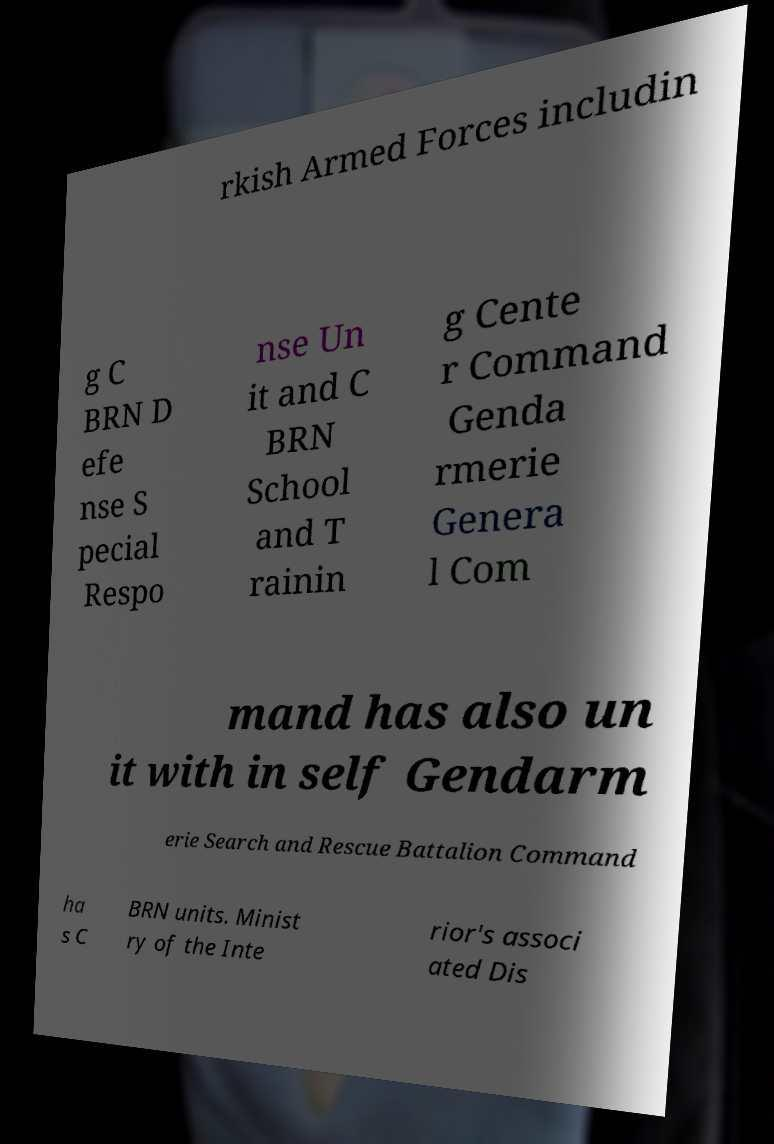Please identify and transcribe the text found in this image. rkish Armed Forces includin g C BRN D efe nse S pecial Respo nse Un it and C BRN School and T rainin g Cente r Command Genda rmerie Genera l Com mand has also un it with in self Gendarm erie Search and Rescue Battalion Command ha s C BRN units. Minist ry of the Inte rior's associ ated Dis 